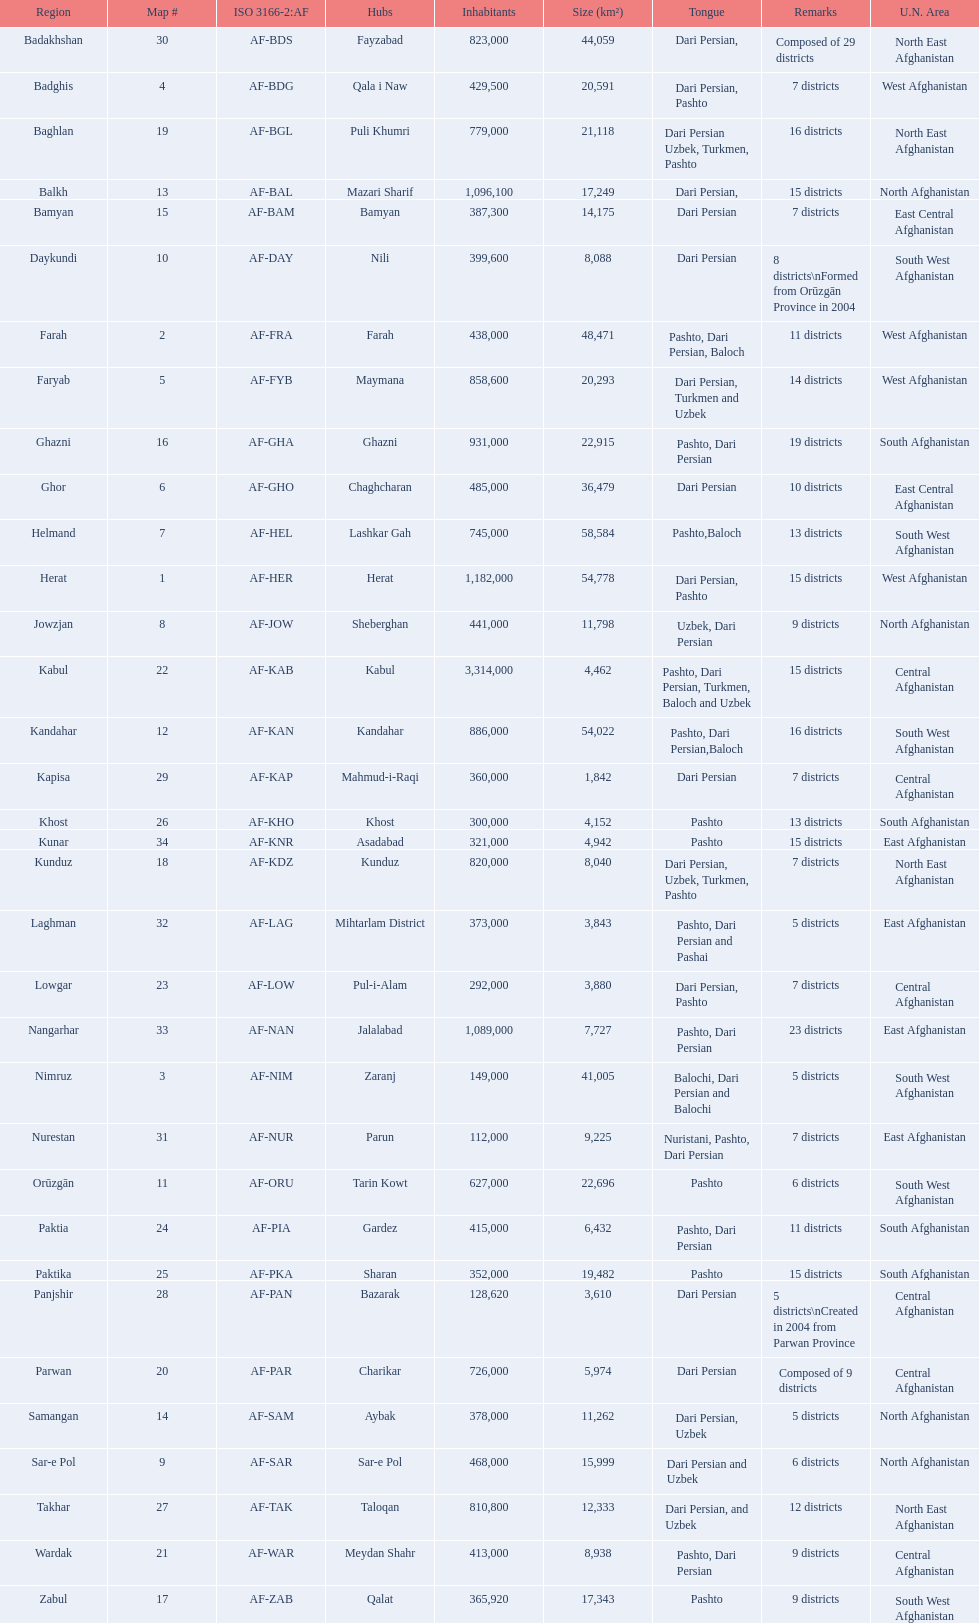What province in afghanistanhas the greatest population? Kabul. 